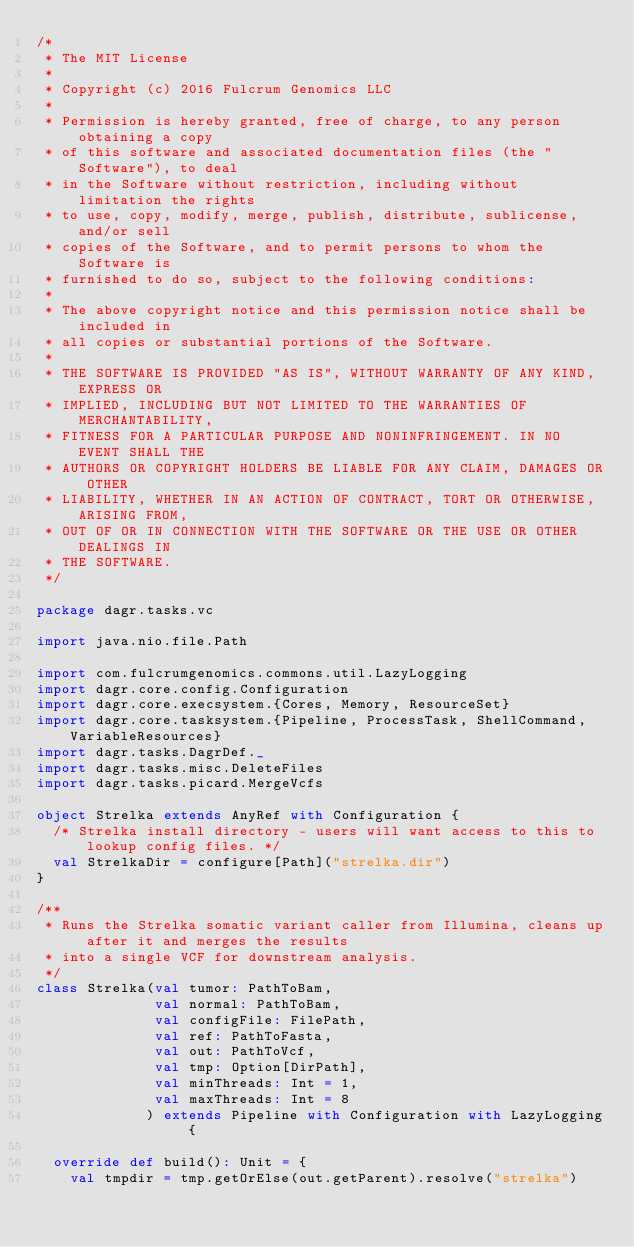Convert code to text. <code><loc_0><loc_0><loc_500><loc_500><_Scala_>/*
 * The MIT License
 *
 * Copyright (c) 2016 Fulcrum Genomics LLC
 *
 * Permission is hereby granted, free of charge, to any person obtaining a copy
 * of this software and associated documentation files (the "Software"), to deal
 * in the Software without restriction, including without limitation the rights
 * to use, copy, modify, merge, publish, distribute, sublicense, and/or sell
 * copies of the Software, and to permit persons to whom the Software is
 * furnished to do so, subject to the following conditions:
 *
 * The above copyright notice and this permission notice shall be included in
 * all copies or substantial portions of the Software.
 *
 * THE SOFTWARE IS PROVIDED "AS IS", WITHOUT WARRANTY OF ANY KIND, EXPRESS OR
 * IMPLIED, INCLUDING BUT NOT LIMITED TO THE WARRANTIES OF MERCHANTABILITY,
 * FITNESS FOR A PARTICULAR PURPOSE AND NONINFRINGEMENT. IN NO EVENT SHALL THE
 * AUTHORS OR COPYRIGHT HOLDERS BE LIABLE FOR ANY CLAIM, DAMAGES OR OTHER
 * LIABILITY, WHETHER IN AN ACTION OF CONTRACT, TORT OR OTHERWISE, ARISING FROM,
 * OUT OF OR IN CONNECTION WITH THE SOFTWARE OR THE USE OR OTHER DEALINGS IN
 * THE SOFTWARE.
 */

package dagr.tasks.vc

import java.nio.file.Path

import com.fulcrumgenomics.commons.util.LazyLogging
import dagr.core.config.Configuration
import dagr.core.execsystem.{Cores, Memory, ResourceSet}
import dagr.core.tasksystem.{Pipeline, ProcessTask, ShellCommand, VariableResources}
import dagr.tasks.DagrDef._
import dagr.tasks.misc.DeleteFiles
import dagr.tasks.picard.MergeVcfs

object Strelka extends AnyRef with Configuration {
  /* Strelka install directory - users will want access to this to lookup config files. */
  val StrelkaDir = configure[Path]("strelka.dir")
}

/**
 * Runs the Strelka somatic variant caller from Illumina, cleans up after it and merges the results
 * into a single VCF for downstream analysis.
 */
class Strelka(val tumor: PathToBam,
              val normal: PathToBam,
              val configFile: FilePath,
              val ref: PathToFasta,
              val out: PathToVcf,
              val tmp: Option[DirPath],
              val minThreads: Int = 1,
              val maxThreads: Int = 8
             ) extends Pipeline with Configuration with LazyLogging {

  override def build(): Unit = {
    val tmpdir = tmp.getOrElse(out.getParent).resolve("strelka")
</code> 